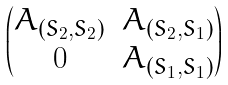<formula> <loc_0><loc_0><loc_500><loc_500>\begin{pmatrix} A _ { ( S _ { 2 } , S _ { 2 } ) } & A _ { ( S _ { 2 } , S _ { 1 } ) } \\ 0 & A _ { ( S _ { 1 } , S _ { 1 } ) } \end{pmatrix}</formula> 